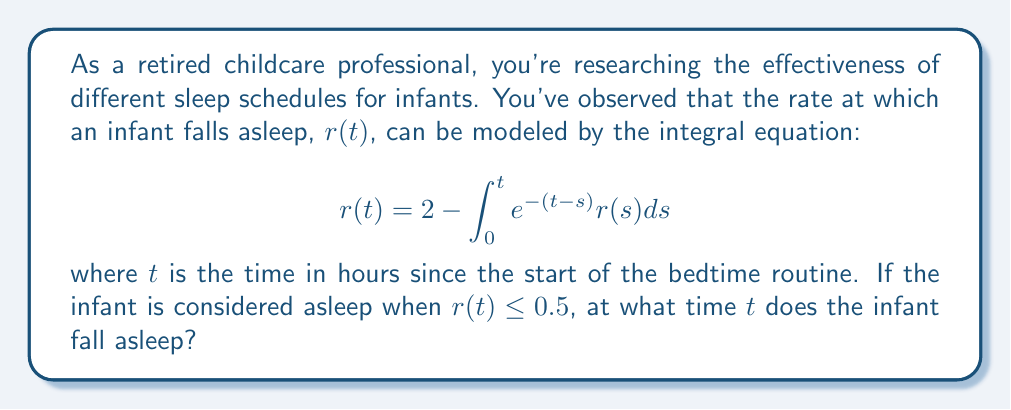Can you answer this question? To solve this integral equation and find when the infant falls asleep, we'll follow these steps:

1) First, we need to differentiate both sides of the equation with respect to $t$:

   $$\frac{d}{dt}r(t) = \frac{d}{dt}\left(2 - \int_0^t e^{-(t-s)}r(s)ds\right)$$

2) Using the fundamental theorem of calculus and the chain rule, we get:

   $$r'(t) = -e^{-(t-t)}r(t) + \int_0^t e^{-(t-s)}r(s) \cdot \frac{d}{dt}(-t)ds$$
   $$r'(t) = -r(t) - \int_0^t e^{-(t-s)}r(s)ds$$

3) Substituting the original equation for the integral term:

   $$r'(t) = -r(t) - (2 - r(t)) = -2$$

4) We now have a simple differential equation: $r'(t) = -2$

5) Integrating both sides:

   $$r(t) = -2t + C$$

6) To find $C$, we use the initial condition $r(0) = 2$ (from the original equation):

   $$2 = -2(0) + C$$
   $$C = 2$$

7) Therefore, the solution is:

   $$r(t) = -2t + 2$$

8) To find when the infant falls asleep, we solve $r(t) = 0.5$:

   $$0.5 = -2t + 2$$
   $$1.5 = 2t$$
   $$t = 0.75$$

Thus, the infant falls asleep after 0.75 hours, or 45 minutes.
Answer: 0.75 hours 